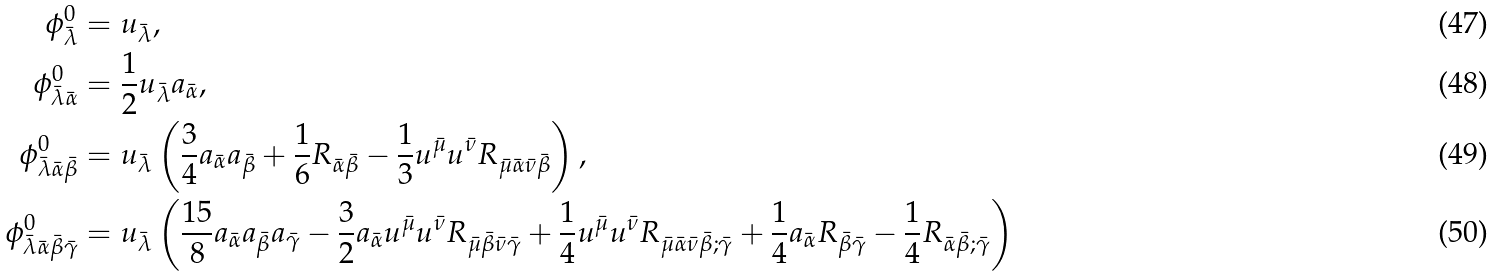<formula> <loc_0><loc_0><loc_500><loc_500>\phi ^ { 0 } _ { \bar { \lambda } } & = u _ { \bar { \lambda } } , \\ \phi ^ { 0 } _ { \bar { \lambda } \bar { \alpha } } & = \frac { 1 } { 2 } u _ { \bar { \lambda } } a _ { \bar { \alpha } } , \\ \phi ^ { 0 } _ { \bar { \lambda } \bar { \alpha } \bar { \beta } } & = u _ { \bar { \lambda } } \left ( \frac { 3 } { 4 } a _ { \bar { \alpha } } a _ { \bar { \beta } } + \frac { 1 } { 6 } R _ { \bar { \alpha } \bar { \beta } } - \frac { 1 } { 3 } u ^ { \bar { \mu } } u ^ { \bar { \nu } } R _ { \bar { \mu } \bar { \alpha } \bar { \nu } \bar { \beta } } \right ) , \\ \phi ^ { 0 } _ { \bar { \lambda } \bar { \alpha } \bar { \beta } \bar { \gamma } } & = u _ { \bar { \lambda } } \left ( \frac { 1 5 } { 8 } a _ { \bar { \alpha } } a _ { \bar { \beta } } a _ { \bar { \gamma } } - \frac { 3 } { 2 } a _ { \bar { \alpha } } u ^ { \bar { \mu } } u ^ { \bar { \nu } } R _ { \bar { \mu } \bar { \beta } \bar { \nu } \bar { \gamma } } + \frac { 1 } { 4 } u ^ { \bar { \mu } } u ^ { \bar { \nu } } R _ { \bar { \mu } \bar { \alpha } \bar { \nu } \bar { \beta } ; \bar { \gamma } } + \frac { 1 } { 4 } a _ { \bar { \alpha } } R _ { \bar { \beta } \bar { \gamma } } - \frac { 1 } { 4 } R _ { \bar { \alpha } \bar { \beta } ; \bar { \gamma } } \right )</formula> 